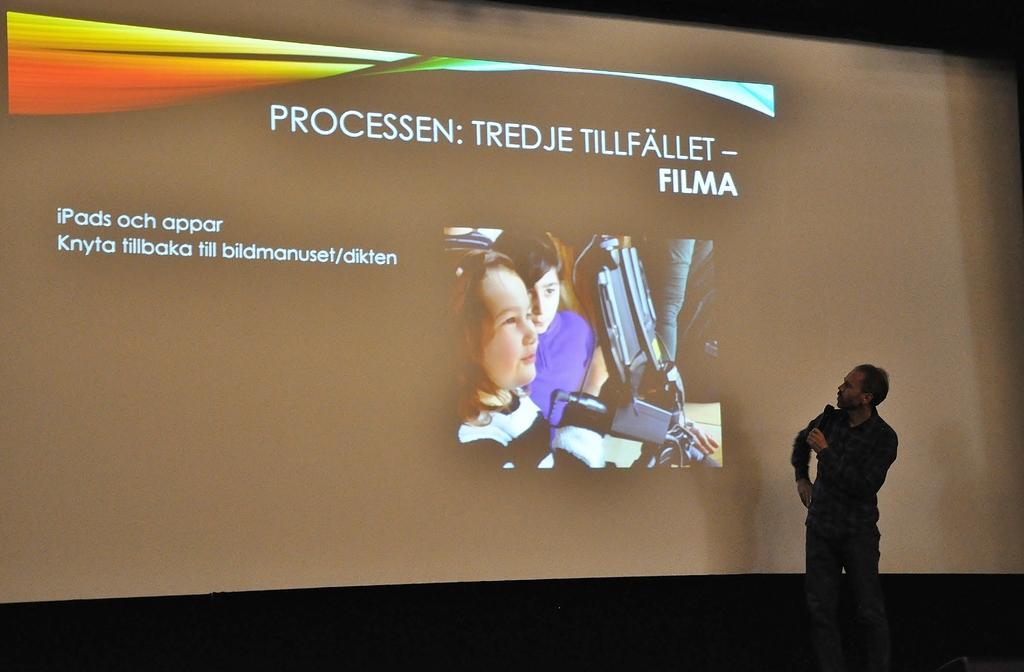In one or two sentences, can you explain what this image depicts? On the right there is a man who is wearing shirt, jeans and shoes. He is holding a mic. Besides him we can see a projector screen. In the projector screen there are two children who are looking to the microscope. Here we can see something is written in english. On the bottom we can see darkness. 